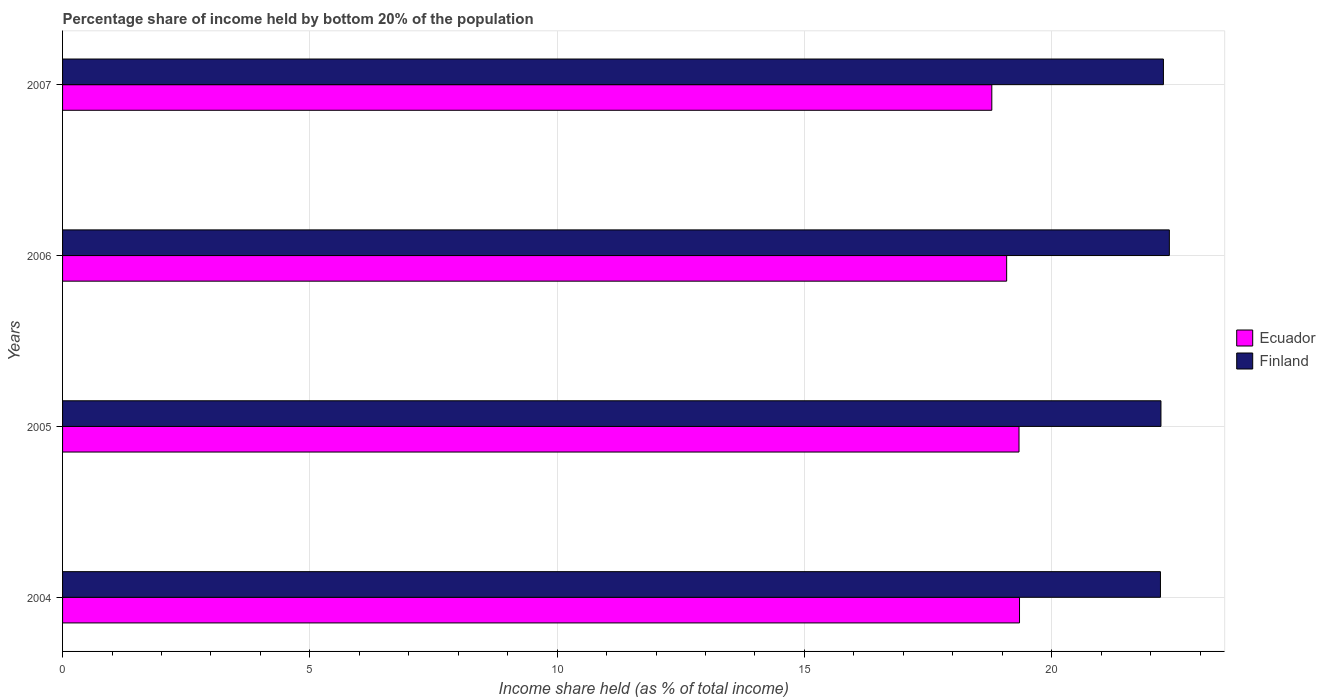How many different coloured bars are there?
Keep it short and to the point. 2. How many groups of bars are there?
Your answer should be very brief. 4. Are the number of bars per tick equal to the number of legend labels?
Ensure brevity in your answer.  Yes. Are the number of bars on each tick of the Y-axis equal?
Provide a succinct answer. Yes. What is the label of the 4th group of bars from the top?
Keep it short and to the point. 2004. What is the share of income held by bottom 20% of the population in Ecuador in 2005?
Keep it short and to the point. 19.34. Across all years, what is the maximum share of income held by bottom 20% of the population in Finland?
Offer a very short reply. 22.38. What is the total share of income held by bottom 20% of the population in Ecuador in the graph?
Provide a succinct answer. 76.57. What is the difference between the share of income held by bottom 20% of the population in Ecuador in 2004 and that in 2006?
Provide a short and direct response. 0.26. What is the difference between the share of income held by bottom 20% of the population in Ecuador in 2004 and the share of income held by bottom 20% of the population in Finland in 2006?
Provide a short and direct response. -3.03. What is the average share of income held by bottom 20% of the population in Ecuador per year?
Keep it short and to the point. 19.14. In the year 2004, what is the difference between the share of income held by bottom 20% of the population in Ecuador and share of income held by bottom 20% of the population in Finland?
Make the answer very short. -2.85. In how many years, is the share of income held by bottom 20% of the population in Ecuador greater than 15 %?
Your response must be concise. 4. What is the ratio of the share of income held by bottom 20% of the population in Finland in 2006 to that in 2007?
Give a very brief answer. 1.01. Is the difference between the share of income held by bottom 20% of the population in Ecuador in 2004 and 2006 greater than the difference between the share of income held by bottom 20% of the population in Finland in 2004 and 2006?
Keep it short and to the point. Yes. What is the difference between the highest and the second highest share of income held by bottom 20% of the population in Ecuador?
Offer a very short reply. 0.01. What is the difference between the highest and the lowest share of income held by bottom 20% of the population in Finland?
Provide a succinct answer. 0.18. Is the sum of the share of income held by bottom 20% of the population in Ecuador in 2004 and 2005 greater than the maximum share of income held by bottom 20% of the population in Finland across all years?
Provide a succinct answer. Yes. What does the 1st bar from the bottom in 2005 represents?
Your answer should be very brief. Ecuador. Are all the bars in the graph horizontal?
Provide a short and direct response. Yes. How many years are there in the graph?
Your response must be concise. 4. Are the values on the major ticks of X-axis written in scientific E-notation?
Provide a succinct answer. No. Does the graph contain any zero values?
Provide a short and direct response. No. Does the graph contain grids?
Offer a very short reply. Yes. How many legend labels are there?
Offer a terse response. 2. How are the legend labels stacked?
Your answer should be compact. Vertical. What is the title of the graph?
Offer a very short reply. Percentage share of income held by bottom 20% of the population. Does "Cyprus" appear as one of the legend labels in the graph?
Provide a succinct answer. No. What is the label or title of the X-axis?
Your response must be concise. Income share held (as % of total income). What is the Income share held (as % of total income) in Ecuador in 2004?
Keep it short and to the point. 19.35. What is the Income share held (as % of total income) in Finland in 2004?
Provide a short and direct response. 22.2. What is the Income share held (as % of total income) in Ecuador in 2005?
Provide a succinct answer. 19.34. What is the Income share held (as % of total income) in Finland in 2005?
Your response must be concise. 22.21. What is the Income share held (as % of total income) of Ecuador in 2006?
Keep it short and to the point. 19.09. What is the Income share held (as % of total income) of Finland in 2006?
Your answer should be compact. 22.38. What is the Income share held (as % of total income) in Ecuador in 2007?
Keep it short and to the point. 18.79. What is the Income share held (as % of total income) of Finland in 2007?
Your answer should be very brief. 22.26. Across all years, what is the maximum Income share held (as % of total income) in Ecuador?
Your answer should be very brief. 19.35. Across all years, what is the maximum Income share held (as % of total income) in Finland?
Provide a short and direct response. 22.38. Across all years, what is the minimum Income share held (as % of total income) of Ecuador?
Offer a terse response. 18.79. Across all years, what is the minimum Income share held (as % of total income) in Finland?
Your answer should be very brief. 22.2. What is the total Income share held (as % of total income) in Ecuador in the graph?
Provide a short and direct response. 76.57. What is the total Income share held (as % of total income) in Finland in the graph?
Keep it short and to the point. 89.05. What is the difference between the Income share held (as % of total income) of Finland in 2004 and that in 2005?
Give a very brief answer. -0.01. What is the difference between the Income share held (as % of total income) of Ecuador in 2004 and that in 2006?
Offer a terse response. 0.26. What is the difference between the Income share held (as % of total income) in Finland in 2004 and that in 2006?
Your response must be concise. -0.18. What is the difference between the Income share held (as % of total income) in Ecuador in 2004 and that in 2007?
Keep it short and to the point. 0.56. What is the difference between the Income share held (as % of total income) in Finland in 2004 and that in 2007?
Make the answer very short. -0.06. What is the difference between the Income share held (as % of total income) of Finland in 2005 and that in 2006?
Give a very brief answer. -0.17. What is the difference between the Income share held (as % of total income) in Ecuador in 2005 and that in 2007?
Provide a short and direct response. 0.55. What is the difference between the Income share held (as % of total income) of Ecuador in 2006 and that in 2007?
Give a very brief answer. 0.3. What is the difference between the Income share held (as % of total income) in Finland in 2006 and that in 2007?
Your answer should be compact. 0.12. What is the difference between the Income share held (as % of total income) of Ecuador in 2004 and the Income share held (as % of total income) of Finland in 2005?
Your answer should be very brief. -2.86. What is the difference between the Income share held (as % of total income) in Ecuador in 2004 and the Income share held (as % of total income) in Finland in 2006?
Your response must be concise. -3.03. What is the difference between the Income share held (as % of total income) of Ecuador in 2004 and the Income share held (as % of total income) of Finland in 2007?
Offer a very short reply. -2.91. What is the difference between the Income share held (as % of total income) in Ecuador in 2005 and the Income share held (as % of total income) in Finland in 2006?
Your answer should be very brief. -3.04. What is the difference between the Income share held (as % of total income) of Ecuador in 2005 and the Income share held (as % of total income) of Finland in 2007?
Ensure brevity in your answer.  -2.92. What is the difference between the Income share held (as % of total income) in Ecuador in 2006 and the Income share held (as % of total income) in Finland in 2007?
Your answer should be very brief. -3.17. What is the average Income share held (as % of total income) in Ecuador per year?
Offer a terse response. 19.14. What is the average Income share held (as % of total income) in Finland per year?
Give a very brief answer. 22.26. In the year 2004, what is the difference between the Income share held (as % of total income) in Ecuador and Income share held (as % of total income) in Finland?
Your answer should be compact. -2.85. In the year 2005, what is the difference between the Income share held (as % of total income) of Ecuador and Income share held (as % of total income) of Finland?
Your answer should be compact. -2.87. In the year 2006, what is the difference between the Income share held (as % of total income) in Ecuador and Income share held (as % of total income) in Finland?
Keep it short and to the point. -3.29. In the year 2007, what is the difference between the Income share held (as % of total income) of Ecuador and Income share held (as % of total income) of Finland?
Provide a succinct answer. -3.47. What is the ratio of the Income share held (as % of total income) of Ecuador in 2004 to that in 2006?
Make the answer very short. 1.01. What is the ratio of the Income share held (as % of total income) in Finland in 2004 to that in 2006?
Ensure brevity in your answer.  0.99. What is the ratio of the Income share held (as % of total income) in Ecuador in 2004 to that in 2007?
Give a very brief answer. 1.03. What is the ratio of the Income share held (as % of total income) in Finland in 2004 to that in 2007?
Keep it short and to the point. 1. What is the ratio of the Income share held (as % of total income) in Ecuador in 2005 to that in 2006?
Ensure brevity in your answer.  1.01. What is the ratio of the Income share held (as % of total income) in Ecuador in 2005 to that in 2007?
Your answer should be compact. 1.03. What is the ratio of the Income share held (as % of total income) of Finland in 2005 to that in 2007?
Keep it short and to the point. 1. What is the ratio of the Income share held (as % of total income) in Finland in 2006 to that in 2007?
Provide a succinct answer. 1.01. What is the difference between the highest and the second highest Income share held (as % of total income) of Finland?
Offer a terse response. 0.12. What is the difference between the highest and the lowest Income share held (as % of total income) of Ecuador?
Provide a succinct answer. 0.56. What is the difference between the highest and the lowest Income share held (as % of total income) in Finland?
Your answer should be compact. 0.18. 